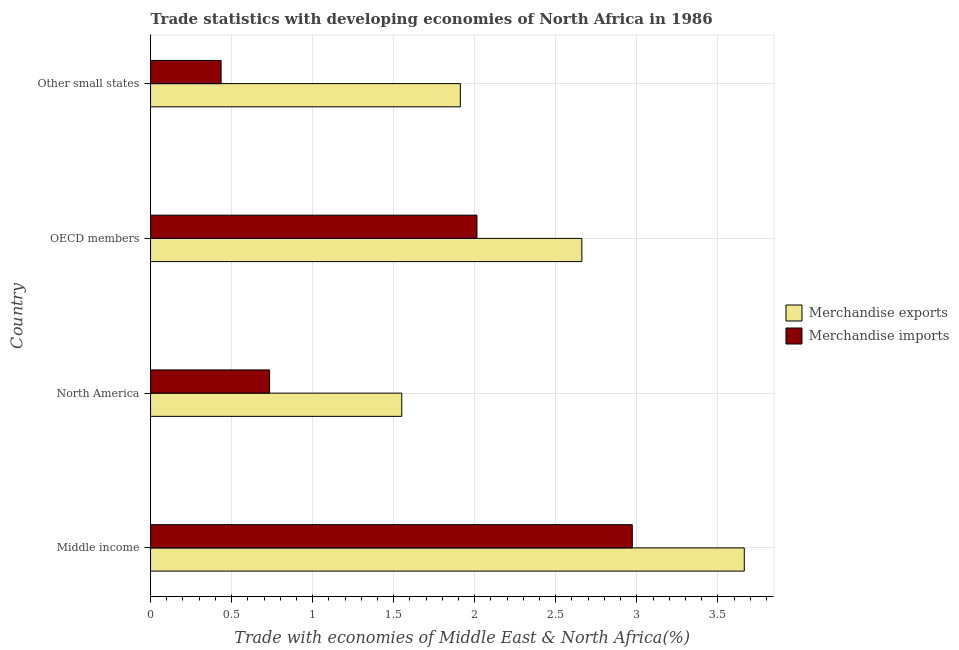Are the number of bars per tick equal to the number of legend labels?
Give a very brief answer. Yes. How many bars are there on the 2nd tick from the bottom?
Offer a terse response. 2. What is the label of the 3rd group of bars from the top?
Your response must be concise. North America. In how many cases, is the number of bars for a given country not equal to the number of legend labels?
Make the answer very short. 0. What is the merchandise exports in Other small states?
Provide a succinct answer. 1.91. Across all countries, what is the maximum merchandise imports?
Make the answer very short. 2.97. Across all countries, what is the minimum merchandise exports?
Keep it short and to the point. 1.55. In which country was the merchandise exports minimum?
Provide a short and direct response. North America. What is the total merchandise imports in the graph?
Provide a succinct answer. 6.16. What is the difference between the merchandise exports in North America and that in OECD members?
Ensure brevity in your answer.  -1.11. What is the difference between the merchandise imports in OECD members and the merchandise exports in North America?
Your response must be concise. 0.46. What is the average merchandise imports per country?
Make the answer very short. 1.54. What is the difference between the merchandise imports and merchandise exports in Other small states?
Keep it short and to the point. -1.48. What is the ratio of the merchandise imports in Middle income to that in OECD members?
Your answer should be compact. 1.48. What is the difference between the highest and the second highest merchandise imports?
Provide a short and direct response. 0.96. What is the difference between the highest and the lowest merchandise exports?
Offer a terse response. 2.11. What does the 1st bar from the top in North America represents?
Ensure brevity in your answer.  Merchandise imports. What does the 1st bar from the bottom in Middle income represents?
Offer a terse response. Merchandise exports. How many bars are there?
Keep it short and to the point. 8. What is the difference between two consecutive major ticks on the X-axis?
Your response must be concise. 0.5. Are the values on the major ticks of X-axis written in scientific E-notation?
Make the answer very short. No. Where does the legend appear in the graph?
Offer a terse response. Center right. How many legend labels are there?
Ensure brevity in your answer.  2. How are the legend labels stacked?
Offer a terse response. Vertical. What is the title of the graph?
Offer a terse response. Trade statistics with developing economies of North Africa in 1986. Does "Urban" appear as one of the legend labels in the graph?
Your answer should be compact. No. What is the label or title of the X-axis?
Offer a very short reply. Trade with economies of Middle East & North Africa(%). What is the label or title of the Y-axis?
Ensure brevity in your answer.  Country. What is the Trade with economies of Middle East & North Africa(%) of Merchandise exports in Middle income?
Provide a succinct answer. 3.66. What is the Trade with economies of Middle East & North Africa(%) in Merchandise imports in Middle income?
Ensure brevity in your answer.  2.97. What is the Trade with economies of Middle East & North Africa(%) in Merchandise exports in North America?
Provide a short and direct response. 1.55. What is the Trade with economies of Middle East & North Africa(%) in Merchandise imports in North America?
Give a very brief answer. 0.73. What is the Trade with economies of Middle East & North Africa(%) in Merchandise exports in OECD members?
Give a very brief answer. 2.66. What is the Trade with economies of Middle East & North Africa(%) of Merchandise imports in OECD members?
Provide a short and direct response. 2.01. What is the Trade with economies of Middle East & North Africa(%) of Merchandise exports in Other small states?
Offer a terse response. 1.91. What is the Trade with economies of Middle East & North Africa(%) in Merchandise imports in Other small states?
Give a very brief answer. 0.44. Across all countries, what is the maximum Trade with economies of Middle East & North Africa(%) of Merchandise exports?
Your answer should be compact. 3.66. Across all countries, what is the maximum Trade with economies of Middle East & North Africa(%) in Merchandise imports?
Your answer should be compact. 2.97. Across all countries, what is the minimum Trade with economies of Middle East & North Africa(%) in Merchandise exports?
Offer a very short reply. 1.55. Across all countries, what is the minimum Trade with economies of Middle East & North Africa(%) in Merchandise imports?
Offer a very short reply. 0.44. What is the total Trade with economies of Middle East & North Africa(%) in Merchandise exports in the graph?
Your response must be concise. 9.78. What is the total Trade with economies of Middle East & North Africa(%) in Merchandise imports in the graph?
Give a very brief answer. 6.16. What is the difference between the Trade with economies of Middle East & North Africa(%) in Merchandise exports in Middle income and that in North America?
Your answer should be compact. 2.11. What is the difference between the Trade with economies of Middle East & North Africa(%) of Merchandise imports in Middle income and that in North America?
Provide a short and direct response. 2.24. What is the difference between the Trade with economies of Middle East & North Africa(%) in Merchandise exports in Middle income and that in Other small states?
Your answer should be compact. 1.75. What is the difference between the Trade with economies of Middle East & North Africa(%) in Merchandise imports in Middle income and that in Other small states?
Your answer should be compact. 2.54. What is the difference between the Trade with economies of Middle East & North Africa(%) of Merchandise exports in North America and that in OECD members?
Your answer should be compact. -1.11. What is the difference between the Trade with economies of Middle East & North Africa(%) of Merchandise imports in North America and that in OECD members?
Give a very brief answer. -1.28. What is the difference between the Trade with economies of Middle East & North Africa(%) in Merchandise exports in North America and that in Other small states?
Your answer should be compact. -0.36. What is the difference between the Trade with economies of Middle East & North Africa(%) in Merchandise imports in North America and that in Other small states?
Provide a short and direct response. 0.3. What is the difference between the Trade with economies of Middle East & North Africa(%) of Merchandise exports in OECD members and that in Other small states?
Provide a short and direct response. 0.75. What is the difference between the Trade with economies of Middle East & North Africa(%) in Merchandise imports in OECD members and that in Other small states?
Ensure brevity in your answer.  1.58. What is the difference between the Trade with economies of Middle East & North Africa(%) of Merchandise exports in Middle income and the Trade with economies of Middle East & North Africa(%) of Merchandise imports in North America?
Ensure brevity in your answer.  2.93. What is the difference between the Trade with economies of Middle East & North Africa(%) of Merchandise exports in Middle income and the Trade with economies of Middle East & North Africa(%) of Merchandise imports in OECD members?
Your response must be concise. 1.65. What is the difference between the Trade with economies of Middle East & North Africa(%) in Merchandise exports in Middle income and the Trade with economies of Middle East & North Africa(%) in Merchandise imports in Other small states?
Give a very brief answer. 3.23. What is the difference between the Trade with economies of Middle East & North Africa(%) of Merchandise exports in North America and the Trade with economies of Middle East & North Africa(%) of Merchandise imports in OECD members?
Give a very brief answer. -0.46. What is the difference between the Trade with economies of Middle East & North Africa(%) of Merchandise exports in North America and the Trade with economies of Middle East & North Africa(%) of Merchandise imports in Other small states?
Provide a short and direct response. 1.11. What is the difference between the Trade with economies of Middle East & North Africa(%) of Merchandise exports in OECD members and the Trade with economies of Middle East & North Africa(%) of Merchandise imports in Other small states?
Give a very brief answer. 2.23. What is the average Trade with economies of Middle East & North Africa(%) of Merchandise exports per country?
Your answer should be very brief. 2.45. What is the average Trade with economies of Middle East & North Africa(%) in Merchandise imports per country?
Your response must be concise. 1.54. What is the difference between the Trade with economies of Middle East & North Africa(%) of Merchandise exports and Trade with economies of Middle East & North Africa(%) of Merchandise imports in Middle income?
Give a very brief answer. 0.69. What is the difference between the Trade with economies of Middle East & North Africa(%) in Merchandise exports and Trade with economies of Middle East & North Africa(%) in Merchandise imports in North America?
Your answer should be very brief. 0.82. What is the difference between the Trade with economies of Middle East & North Africa(%) in Merchandise exports and Trade with economies of Middle East & North Africa(%) in Merchandise imports in OECD members?
Provide a short and direct response. 0.65. What is the difference between the Trade with economies of Middle East & North Africa(%) in Merchandise exports and Trade with economies of Middle East & North Africa(%) in Merchandise imports in Other small states?
Offer a terse response. 1.48. What is the ratio of the Trade with economies of Middle East & North Africa(%) in Merchandise exports in Middle income to that in North America?
Keep it short and to the point. 2.36. What is the ratio of the Trade with economies of Middle East & North Africa(%) in Merchandise imports in Middle income to that in North America?
Your answer should be compact. 4.05. What is the ratio of the Trade with economies of Middle East & North Africa(%) of Merchandise exports in Middle income to that in OECD members?
Make the answer very short. 1.38. What is the ratio of the Trade with economies of Middle East & North Africa(%) in Merchandise imports in Middle income to that in OECD members?
Offer a very short reply. 1.48. What is the ratio of the Trade with economies of Middle East & North Africa(%) in Merchandise exports in Middle income to that in Other small states?
Give a very brief answer. 1.92. What is the ratio of the Trade with economies of Middle East & North Africa(%) in Merchandise imports in Middle income to that in Other small states?
Your answer should be very brief. 6.83. What is the ratio of the Trade with economies of Middle East & North Africa(%) of Merchandise exports in North America to that in OECD members?
Give a very brief answer. 0.58. What is the ratio of the Trade with economies of Middle East & North Africa(%) in Merchandise imports in North America to that in OECD members?
Keep it short and to the point. 0.36. What is the ratio of the Trade with economies of Middle East & North Africa(%) of Merchandise exports in North America to that in Other small states?
Provide a short and direct response. 0.81. What is the ratio of the Trade with economies of Middle East & North Africa(%) in Merchandise imports in North America to that in Other small states?
Ensure brevity in your answer.  1.69. What is the ratio of the Trade with economies of Middle East & North Africa(%) of Merchandise exports in OECD members to that in Other small states?
Ensure brevity in your answer.  1.39. What is the ratio of the Trade with economies of Middle East & North Africa(%) in Merchandise imports in OECD members to that in Other small states?
Ensure brevity in your answer.  4.63. What is the difference between the highest and the second highest Trade with economies of Middle East & North Africa(%) of Merchandise exports?
Your response must be concise. 1. What is the difference between the highest and the second highest Trade with economies of Middle East & North Africa(%) in Merchandise imports?
Offer a terse response. 0.96. What is the difference between the highest and the lowest Trade with economies of Middle East & North Africa(%) of Merchandise exports?
Offer a very short reply. 2.11. What is the difference between the highest and the lowest Trade with economies of Middle East & North Africa(%) of Merchandise imports?
Your response must be concise. 2.54. 